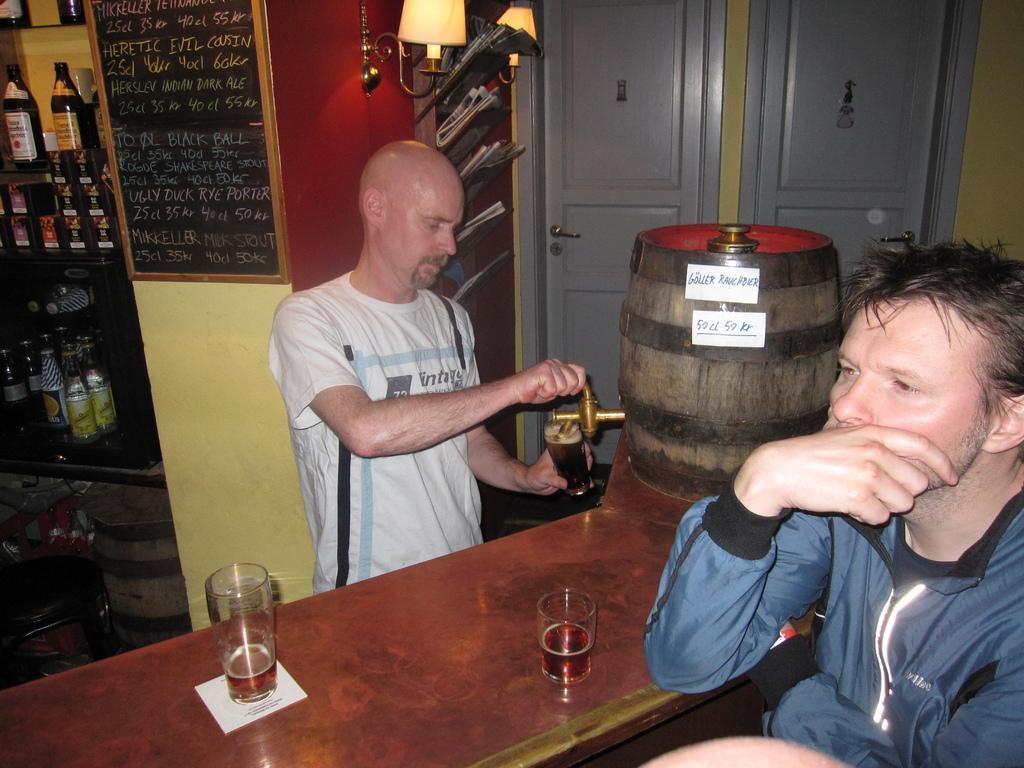Describe this image in one or two sentences. In the image we can see two men wearing clothes and the left side man is holding glass in one hand and on the other hand he is holding the tap. Here we can see the table and on the table, we can see the glasses. Here we can see bottles kept on the shelves. Here we can see lights, doors, board and text on the board. 